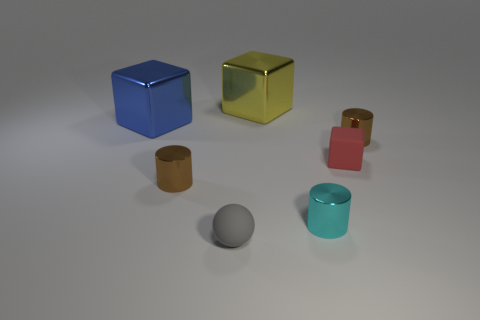Is the number of cyan cylinders to the right of the ball less than the number of gray rubber balls that are right of the yellow metal block?
Your response must be concise. No. What number of shiny things are tiny cylinders or brown cylinders?
Your answer should be very brief. 3. The gray object has what shape?
Make the answer very short. Sphere. What is the material of the blue object that is the same size as the yellow shiny block?
Your answer should be compact. Metal. What number of small things are purple metallic objects or yellow metal things?
Your answer should be compact. 0. Are any tiny shiny cylinders visible?
Your answer should be very brief. Yes. There is a blue thing that is made of the same material as the large yellow object; what size is it?
Offer a very short reply. Large. Does the yellow object have the same material as the big blue cube?
Your answer should be very brief. Yes. How many other things are made of the same material as the red object?
Keep it short and to the point. 1. What number of shiny things are to the left of the small gray matte sphere and in front of the tiny rubber cube?
Provide a succinct answer. 1. 